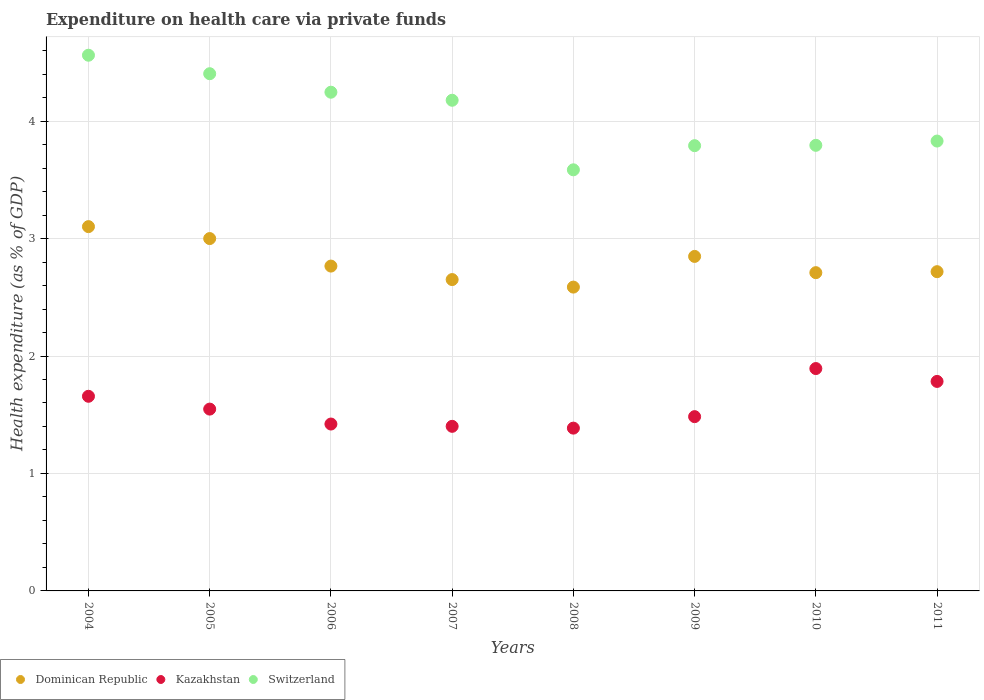Is the number of dotlines equal to the number of legend labels?
Make the answer very short. Yes. What is the expenditure made on health care in Switzerland in 2005?
Give a very brief answer. 4.4. Across all years, what is the maximum expenditure made on health care in Dominican Republic?
Offer a very short reply. 3.1. Across all years, what is the minimum expenditure made on health care in Kazakhstan?
Your response must be concise. 1.39. What is the total expenditure made on health care in Switzerland in the graph?
Ensure brevity in your answer.  32.39. What is the difference between the expenditure made on health care in Switzerland in 2004 and that in 2006?
Keep it short and to the point. 0.31. What is the difference between the expenditure made on health care in Kazakhstan in 2006 and the expenditure made on health care in Switzerland in 2007?
Your answer should be very brief. -2.76. What is the average expenditure made on health care in Switzerland per year?
Your response must be concise. 4.05. In the year 2010, what is the difference between the expenditure made on health care in Dominican Republic and expenditure made on health care in Switzerland?
Make the answer very short. -1.08. What is the ratio of the expenditure made on health care in Switzerland in 2008 to that in 2009?
Your answer should be compact. 0.95. Is the difference between the expenditure made on health care in Dominican Republic in 2010 and 2011 greater than the difference between the expenditure made on health care in Switzerland in 2010 and 2011?
Your answer should be compact. Yes. What is the difference between the highest and the second highest expenditure made on health care in Switzerland?
Your answer should be very brief. 0.16. What is the difference between the highest and the lowest expenditure made on health care in Dominican Republic?
Offer a terse response. 0.51. Is the expenditure made on health care in Switzerland strictly greater than the expenditure made on health care in Kazakhstan over the years?
Keep it short and to the point. Yes. How many dotlines are there?
Provide a short and direct response. 3. How many years are there in the graph?
Provide a succinct answer. 8. Are the values on the major ticks of Y-axis written in scientific E-notation?
Keep it short and to the point. No. Does the graph contain any zero values?
Offer a very short reply. No. Where does the legend appear in the graph?
Offer a terse response. Bottom left. How many legend labels are there?
Provide a short and direct response. 3. What is the title of the graph?
Your answer should be compact. Expenditure on health care via private funds. Does "Papua New Guinea" appear as one of the legend labels in the graph?
Provide a succinct answer. No. What is the label or title of the Y-axis?
Offer a terse response. Health expenditure (as % of GDP). What is the Health expenditure (as % of GDP) of Dominican Republic in 2004?
Your response must be concise. 3.1. What is the Health expenditure (as % of GDP) in Kazakhstan in 2004?
Keep it short and to the point. 1.66. What is the Health expenditure (as % of GDP) in Switzerland in 2004?
Your answer should be compact. 4.56. What is the Health expenditure (as % of GDP) of Dominican Republic in 2005?
Your response must be concise. 3. What is the Health expenditure (as % of GDP) in Kazakhstan in 2005?
Your answer should be very brief. 1.55. What is the Health expenditure (as % of GDP) of Switzerland in 2005?
Ensure brevity in your answer.  4.4. What is the Health expenditure (as % of GDP) in Dominican Republic in 2006?
Offer a very short reply. 2.77. What is the Health expenditure (as % of GDP) in Kazakhstan in 2006?
Keep it short and to the point. 1.42. What is the Health expenditure (as % of GDP) of Switzerland in 2006?
Make the answer very short. 4.25. What is the Health expenditure (as % of GDP) in Dominican Republic in 2007?
Your answer should be compact. 2.65. What is the Health expenditure (as % of GDP) in Kazakhstan in 2007?
Make the answer very short. 1.4. What is the Health expenditure (as % of GDP) of Switzerland in 2007?
Provide a short and direct response. 4.18. What is the Health expenditure (as % of GDP) of Dominican Republic in 2008?
Offer a terse response. 2.59. What is the Health expenditure (as % of GDP) of Kazakhstan in 2008?
Provide a succinct answer. 1.39. What is the Health expenditure (as % of GDP) of Switzerland in 2008?
Offer a terse response. 3.59. What is the Health expenditure (as % of GDP) in Dominican Republic in 2009?
Your response must be concise. 2.85. What is the Health expenditure (as % of GDP) in Kazakhstan in 2009?
Your response must be concise. 1.48. What is the Health expenditure (as % of GDP) of Switzerland in 2009?
Offer a very short reply. 3.79. What is the Health expenditure (as % of GDP) in Dominican Republic in 2010?
Offer a very short reply. 2.71. What is the Health expenditure (as % of GDP) of Kazakhstan in 2010?
Give a very brief answer. 1.89. What is the Health expenditure (as % of GDP) in Switzerland in 2010?
Keep it short and to the point. 3.79. What is the Health expenditure (as % of GDP) of Dominican Republic in 2011?
Offer a terse response. 2.72. What is the Health expenditure (as % of GDP) in Kazakhstan in 2011?
Provide a succinct answer. 1.78. What is the Health expenditure (as % of GDP) in Switzerland in 2011?
Your response must be concise. 3.83. Across all years, what is the maximum Health expenditure (as % of GDP) of Dominican Republic?
Your answer should be compact. 3.1. Across all years, what is the maximum Health expenditure (as % of GDP) of Kazakhstan?
Provide a short and direct response. 1.89. Across all years, what is the maximum Health expenditure (as % of GDP) in Switzerland?
Offer a very short reply. 4.56. Across all years, what is the minimum Health expenditure (as % of GDP) in Dominican Republic?
Offer a very short reply. 2.59. Across all years, what is the minimum Health expenditure (as % of GDP) in Kazakhstan?
Your response must be concise. 1.39. Across all years, what is the minimum Health expenditure (as % of GDP) in Switzerland?
Offer a very short reply. 3.59. What is the total Health expenditure (as % of GDP) in Dominican Republic in the graph?
Offer a very short reply. 22.38. What is the total Health expenditure (as % of GDP) of Kazakhstan in the graph?
Offer a very short reply. 12.57. What is the total Health expenditure (as % of GDP) in Switzerland in the graph?
Offer a very short reply. 32.39. What is the difference between the Health expenditure (as % of GDP) of Dominican Republic in 2004 and that in 2005?
Offer a very short reply. 0.1. What is the difference between the Health expenditure (as % of GDP) of Kazakhstan in 2004 and that in 2005?
Ensure brevity in your answer.  0.11. What is the difference between the Health expenditure (as % of GDP) in Switzerland in 2004 and that in 2005?
Your response must be concise. 0.16. What is the difference between the Health expenditure (as % of GDP) of Dominican Republic in 2004 and that in 2006?
Offer a very short reply. 0.34. What is the difference between the Health expenditure (as % of GDP) in Kazakhstan in 2004 and that in 2006?
Offer a very short reply. 0.24. What is the difference between the Health expenditure (as % of GDP) of Switzerland in 2004 and that in 2006?
Provide a short and direct response. 0.31. What is the difference between the Health expenditure (as % of GDP) in Dominican Republic in 2004 and that in 2007?
Make the answer very short. 0.45. What is the difference between the Health expenditure (as % of GDP) in Kazakhstan in 2004 and that in 2007?
Your response must be concise. 0.26. What is the difference between the Health expenditure (as % of GDP) in Switzerland in 2004 and that in 2007?
Provide a short and direct response. 0.38. What is the difference between the Health expenditure (as % of GDP) of Dominican Republic in 2004 and that in 2008?
Your answer should be compact. 0.51. What is the difference between the Health expenditure (as % of GDP) in Kazakhstan in 2004 and that in 2008?
Keep it short and to the point. 0.27. What is the difference between the Health expenditure (as % of GDP) of Switzerland in 2004 and that in 2008?
Offer a very short reply. 0.98. What is the difference between the Health expenditure (as % of GDP) of Dominican Republic in 2004 and that in 2009?
Ensure brevity in your answer.  0.25. What is the difference between the Health expenditure (as % of GDP) in Kazakhstan in 2004 and that in 2009?
Keep it short and to the point. 0.17. What is the difference between the Health expenditure (as % of GDP) in Switzerland in 2004 and that in 2009?
Keep it short and to the point. 0.77. What is the difference between the Health expenditure (as % of GDP) of Dominican Republic in 2004 and that in 2010?
Your answer should be compact. 0.39. What is the difference between the Health expenditure (as % of GDP) in Kazakhstan in 2004 and that in 2010?
Give a very brief answer. -0.24. What is the difference between the Health expenditure (as % of GDP) of Switzerland in 2004 and that in 2010?
Ensure brevity in your answer.  0.77. What is the difference between the Health expenditure (as % of GDP) in Dominican Republic in 2004 and that in 2011?
Your response must be concise. 0.38. What is the difference between the Health expenditure (as % of GDP) in Kazakhstan in 2004 and that in 2011?
Keep it short and to the point. -0.13. What is the difference between the Health expenditure (as % of GDP) of Switzerland in 2004 and that in 2011?
Offer a terse response. 0.73. What is the difference between the Health expenditure (as % of GDP) of Dominican Republic in 2005 and that in 2006?
Make the answer very short. 0.23. What is the difference between the Health expenditure (as % of GDP) in Kazakhstan in 2005 and that in 2006?
Provide a succinct answer. 0.13. What is the difference between the Health expenditure (as % of GDP) of Switzerland in 2005 and that in 2006?
Ensure brevity in your answer.  0.16. What is the difference between the Health expenditure (as % of GDP) of Dominican Republic in 2005 and that in 2007?
Provide a short and direct response. 0.35. What is the difference between the Health expenditure (as % of GDP) of Kazakhstan in 2005 and that in 2007?
Offer a very short reply. 0.15. What is the difference between the Health expenditure (as % of GDP) of Switzerland in 2005 and that in 2007?
Offer a very short reply. 0.23. What is the difference between the Health expenditure (as % of GDP) of Dominican Republic in 2005 and that in 2008?
Provide a succinct answer. 0.41. What is the difference between the Health expenditure (as % of GDP) in Kazakhstan in 2005 and that in 2008?
Offer a very short reply. 0.16. What is the difference between the Health expenditure (as % of GDP) in Switzerland in 2005 and that in 2008?
Your answer should be compact. 0.82. What is the difference between the Health expenditure (as % of GDP) in Dominican Republic in 2005 and that in 2009?
Give a very brief answer. 0.15. What is the difference between the Health expenditure (as % of GDP) in Kazakhstan in 2005 and that in 2009?
Give a very brief answer. 0.06. What is the difference between the Health expenditure (as % of GDP) of Switzerland in 2005 and that in 2009?
Provide a succinct answer. 0.61. What is the difference between the Health expenditure (as % of GDP) of Dominican Republic in 2005 and that in 2010?
Your response must be concise. 0.29. What is the difference between the Health expenditure (as % of GDP) of Kazakhstan in 2005 and that in 2010?
Give a very brief answer. -0.35. What is the difference between the Health expenditure (as % of GDP) of Switzerland in 2005 and that in 2010?
Ensure brevity in your answer.  0.61. What is the difference between the Health expenditure (as % of GDP) in Dominican Republic in 2005 and that in 2011?
Make the answer very short. 0.28. What is the difference between the Health expenditure (as % of GDP) of Kazakhstan in 2005 and that in 2011?
Your answer should be very brief. -0.24. What is the difference between the Health expenditure (as % of GDP) in Switzerland in 2005 and that in 2011?
Keep it short and to the point. 0.57. What is the difference between the Health expenditure (as % of GDP) in Dominican Republic in 2006 and that in 2007?
Provide a succinct answer. 0.11. What is the difference between the Health expenditure (as % of GDP) in Kazakhstan in 2006 and that in 2007?
Your response must be concise. 0.02. What is the difference between the Health expenditure (as % of GDP) in Switzerland in 2006 and that in 2007?
Your answer should be very brief. 0.07. What is the difference between the Health expenditure (as % of GDP) in Dominican Republic in 2006 and that in 2008?
Make the answer very short. 0.18. What is the difference between the Health expenditure (as % of GDP) in Kazakhstan in 2006 and that in 2008?
Your answer should be very brief. 0.03. What is the difference between the Health expenditure (as % of GDP) of Switzerland in 2006 and that in 2008?
Make the answer very short. 0.66. What is the difference between the Health expenditure (as % of GDP) of Dominican Republic in 2006 and that in 2009?
Offer a terse response. -0.08. What is the difference between the Health expenditure (as % of GDP) of Kazakhstan in 2006 and that in 2009?
Your response must be concise. -0.06. What is the difference between the Health expenditure (as % of GDP) in Switzerland in 2006 and that in 2009?
Offer a very short reply. 0.46. What is the difference between the Health expenditure (as % of GDP) in Dominican Republic in 2006 and that in 2010?
Keep it short and to the point. 0.06. What is the difference between the Health expenditure (as % of GDP) of Kazakhstan in 2006 and that in 2010?
Make the answer very short. -0.47. What is the difference between the Health expenditure (as % of GDP) of Switzerland in 2006 and that in 2010?
Your answer should be compact. 0.45. What is the difference between the Health expenditure (as % of GDP) of Dominican Republic in 2006 and that in 2011?
Keep it short and to the point. 0.05. What is the difference between the Health expenditure (as % of GDP) in Kazakhstan in 2006 and that in 2011?
Provide a short and direct response. -0.36. What is the difference between the Health expenditure (as % of GDP) in Switzerland in 2006 and that in 2011?
Keep it short and to the point. 0.42. What is the difference between the Health expenditure (as % of GDP) of Dominican Republic in 2007 and that in 2008?
Make the answer very short. 0.06. What is the difference between the Health expenditure (as % of GDP) of Kazakhstan in 2007 and that in 2008?
Keep it short and to the point. 0.02. What is the difference between the Health expenditure (as % of GDP) in Switzerland in 2007 and that in 2008?
Offer a terse response. 0.59. What is the difference between the Health expenditure (as % of GDP) of Dominican Republic in 2007 and that in 2009?
Provide a short and direct response. -0.2. What is the difference between the Health expenditure (as % of GDP) of Kazakhstan in 2007 and that in 2009?
Provide a succinct answer. -0.08. What is the difference between the Health expenditure (as % of GDP) of Switzerland in 2007 and that in 2009?
Give a very brief answer. 0.39. What is the difference between the Health expenditure (as % of GDP) in Dominican Republic in 2007 and that in 2010?
Make the answer very short. -0.06. What is the difference between the Health expenditure (as % of GDP) of Kazakhstan in 2007 and that in 2010?
Provide a short and direct response. -0.49. What is the difference between the Health expenditure (as % of GDP) in Switzerland in 2007 and that in 2010?
Offer a terse response. 0.38. What is the difference between the Health expenditure (as % of GDP) in Dominican Republic in 2007 and that in 2011?
Give a very brief answer. -0.07. What is the difference between the Health expenditure (as % of GDP) of Kazakhstan in 2007 and that in 2011?
Give a very brief answer. -0.38. What is the difference between the Health expenditure (as % of GDP) of Switzerland in 2007 and that in 2011?
Keep it short and to the point. 0.35. What is the difference between the Health expenditure (as % of GDP) in Dominican Republic in 2008 and that in 2009?
Your answer should be very brief. -0.26. What is the difference between the Health expenditure (as % of GDP) in Kazakhstan in 2008 and that in 2009?
Your answer should be compact. -0.1. What is the difference between the Health expenditure (as % of GDP) of Switzerland in 2008 and that in 2009?
Make the answer very short. -0.21. What is the difference between the Health expenditure (as % of GDP) in Dominican Republic in 2008 and that in 2010?
Offer a very short reply. -0.12. What is the difference between the Health expenditure (as % of GDP) in Kazakhstan in 2008 and that in 2010?
Make the answer very short. -0.51. What is the difference between the Health expenditure (as % of GDP) in Switzerland in 2008 and that in 2010?
Ensure brevity in your answer.  -0.21. What is the difference between the Health expenditure (as % of GDP) of Dominican Republic in 2008 and that in 2011?
Ensure brevity in your answer.  -0.13. What is the difference between the Health expenditure (as % of GDP) of Kazakhstan in 2008 and that in 2011?
Provide a succinct answer. -0.4. What is the difference between the Health expenditure (as % of GDP) in Switzerland in 2008 and that in 2011?
Give a very brief answer. -0.24. What is the difference between the Health expenditure (as % of GDP) in Dominican Republic in 2009 and that in 2010?
Your answer should be compact. 0.14. What is the difference between the Health expenditure (as % of GDP) of Kazakhstan in 2009 and that in 2010?
Your answer should be compact. -0.41. What is the difference between the Health expenditure (as % of GDP) of Switzerland in 2009 and that in 2010?
Offer a terse response. -0. What is the difference between the Health expenditure (as % of GDP) of Dominican Republic in 2009 and that in 2011?
Provide a short and direct response. 0.13. What is the difference between the Health expenditure (as % of GDP) of Kazakhstan in 2009 and that in 2011?
Offer a very short reply. -0.3. What is the difference between the Health expenditure (as % of GDP) of Switzerland in 2009 and that in 2011?
Your answer should be compact. -0.04. What is the difference between the Health expenditure (as % of GDP) in Dominican Republic in 2010 and that in 2011?
Offer a terse response. -0.01. What is the difference between the Health expenditure (as % of GDP) of Kazakhstan in 2010 and that in 2011?
Keep it short and to the point. 0.11. What is the difference between the Health expenditure (as % of GDP) in Switzerland in 2010 and that in 2011?
Your answer should be very brief. -0.04. What is the difference between the Health expenditure (as % of GDP) in Dominican Republic in 2004 and the Health expenditure (as % of GDP) in Kazakhstan in 2005?
Offer a terse response. 1.55. What is the difference between the Health expenditure (as % of GDP) in Dominican Republic in 2004 and the Health expenditure (as % of GDP) in Switzerland in 2005?
Offer a very short reply. -1.3. What is the difference between the Health expenditure (as % of GDP) of Kazakhstan in 2004 and the Health expenditure (as % of GDP) of Switzerland in 2005?
Make the answer very short. -2.75. What is the difference between the Health expenditure (as % of GDP) of Dominican Republic in 2004 and the Health expenditure (as % of GDP) of Kazakhstan in 2006?
Keep it short and to the point. 1.68. What is the difference between the Health expenditure (as % of GDP) of Dominican Republic in 2004 and the Health expenditure (as % of GDP) of Switzerland in 2006?
Provide a short and direct response. -1.14. What is the difference between the Health expenditure (as % of GDP) in Kazakhstan in 2004 and the Health expenditure (as % of GDP) in Switzerland in 2006?
Offer a very short reply. -2.59. What is the difference between the Health expenditure (as % of GDP) of Dominican Republic in 2004 and the Health expenditure (as % of GDP) of Kazakhstan in 2007?
Your answer should be very brief. 1.7. What is the difference between the Health expenditure (as % of GDP) in Dominican Republic in 2004 and the Health expenditure (as % of GDP) in Switzerland in 2007?
Offer a very short reply. -1.08. What is the difference between the Health expenditure (as % of GDP) of Kazakhstan in 2004 and the Health expenditure (as % of GDP) of Switzerland in 2007?
Offer a very short reply. -2.52. What is the difference between the Health expenditure (as % of GDP) of Dominican Republic in 2004 and the Health expenditure (as % of GDP) of Kazakhstan in 2008?
Ensure brevity in your answer.  1.72. What is the difference between the Health expenditure (as % of GDP) of Dominican Republic in 2004 and the Health expenditure (as % of GDP) of Switzerland in 2008?
Offer a terse response. -0.48. What is the difference between the Health expenditure (as % of GDP) in Kazakhstan in 2004 and the Health expenditure (as % of GDP) in Switzerland in 2008?
Offer a terse response. -1.93. What is the difference between the Health expenditure (as % of GDP) of Dominican Republic in 2004 and the Health expenditure (as % of GDP) of Kazakhstan in 2009?
Offer a very short reply. 1.62. What is the difference between the Health expenditure (as % of GDP) in Dominican Republic in 2004 and the Health expenditure (as % of GDP) in Switzerland in 2009?
Your response must be concise. -0.69. What is the difference between the Health expenditure (as % of GDP) of Kazakhstan in 2004 and the Health expenditure (as % of GDP) of Switzerland in 2009?
Provide a succinct answer. -2.13. What is the difference between the Health expenditure (as % of GDP) of Dominican Republic in 2004 and the Health expenditure (as % of GDP) of Kazakhstan in 2010?
Offer a very short reply. 1.21. What is the difference between the Health expenditure (as % of GDP) in Dominican Republic in 2004 and the Health expenditure (as % of GDP) in Switzerland in 2010?
Your answer should be very brief. -0.69. What is the difference between the Health expenditure (as % of GDP) in Kazakhstan in 2004 and the Health expenditure (as % of GDP) in Switzerland in 2010?
Ensure brevity in your answer.  -2.14. What is the difference between the Health expenditure (as % of GDP) in Dominican Republic in 2004 and the Health expenditure (as % of GDP) in Kazakhstan in 2011?
Offer a terse response. 1.32. What is the difference between the Health expenditure (as % of GDP) of Dominican Republic in 2004 and the Health expenditure (as % of GDP) of Switzerland in 2011?
Keep it short and to the point. -0.73. What is the difference between the Health expenditure (as % of GDP) in Kazakhstan in 2004 and the Health expenditure (as % of GDP) in Switzerland in 2011?
Keep it short and to the point. -2.17. What is the difference between the Health expenditure (as % of GDP) of Dominican Republic in 2005 and the Health expenditure (as % of GDP) of Kazakhstan in 2006?
Your answer should be compact. 1.58. What is the difference between the Health expenditure (as % of GDP) in Dominican Republic in 2005 and the Health expenditure (as % of GDP) in Switzerland in 2006?
Give a very brief answer. -1.25. What is the difference between the Health expenditure (as % of GDP) in Kazakhstan in 2005 and the Health expenditure (as % of GDP) in Switzerland in 2006?
Give a very brief answer. -2.7. What is the difference between the Health expenditure (as % of GDP) in Dominican Republic in 2005 and the Health expenditure (as % of GDP) in Kazakhstan in 2007?
Ensure brevity in your answer.  1.6. What is the difference between the Health expenditure (as % of GDP) of Dominican Republic in 2005 and the Health expenditure (as % of GDP) of Switzerland in 2007?
Your answer should be very brief. -1.18. What is the difference between the Health expenditure (as % of GDP) in Kazakhstan in 2005 and the Health expenditure (as % of GDP) in Switzerland in 2007?
Your answer should be compact. -2.63. What is the difference between the Health expenditure (as % of GDP) of Dominican Republic in 2005 and the Health expenditure (as % of GDP) of Kazakhstan in 2008?
Make the answer very short. 1.61. What is the difference between the Health expenditure (as % of GDP) of Dominican Republic in 2005 and the Health expenditure (as % of GDP) of Switzerland in 2008?
Give a very brief answer. -0.59. What is the difference between the Health expenditure (as % of GDP) of Kazakhstan in 2005 and the Health expenditure (as % of GDP) of Switzerland in 2008?
Offer a very short reply. -2.04. What is the difference between the Health expenditure (as % of GDP) of Dominican Republic in 2005 and the Health expenditure (as % of GDP) of Kazakhstan in 2009?
Provide a short and direct response. 1.52. What is the difference between the Health expenditure (as % of GDP) in Dominican Republic in 2005 and the Health expenditure (as % of GDP) in Switzerland in 2009?
Offer a very short reply. -0.79. What is the difference between the Health expenditure (as % of GDP) of Kazakhstan in 2005 and the Health expenditure (as % of GDP) of Switzerland in 2009?
Your response must be concise. -2.24. What is the difference between the Health expenditure (as % of GDP) of Dominican Republic in 2005 and the Health expenditure (as % of GDP) of Kazakhstan in 2010?
Keep it short and to the point. 1.11. What is the difference between the Health expenditure (as % of GDP) in Dominican Republic in 2005 and the Health expenditure (as % of GDP) in Switzerland in 2010?
Provide a short and direct response. -0.79. What is the difference between the Health expenditure (as % of GDP) of Kazakhstan in 2005 and the Health expenditure (as % of GDP) of Switzerland in 2010?
Keep it short and to the point. -2.25. What is the difference between the Health expenditure (as % of GDP) of Dominican Republic in 2005 and the Health expenditure (as % of GDP) of Kazakhstan in 2011?
Offer a terse response. 1.22. What is the difference between the Health expenditure (as % of GDP) in Dominican Republic in 2005 and the Health expenditure (as % of GDP) in Switzerland in 2011?
Ensure brevity in your answer.  -0.83. What is the difference between the Health expenditure (as % of GDP) in Kazakhstan in 2005 and the Health expenditure (as % of GDP) in Switzerland in 2011?
Make the answer very short. -2.28. What is the difference between the Health expenditure (as % of GDP) in Dominican Republic in 2006 and the Health expenditure (as % of GDP) in Kazakhstan in 2007?
Provide a succinct answer. 1.36. What is the difference between the Health expenditure (as % of GDP) of Dominican Republic in 2006 and the Health expenditure (as % of GDP) of Switzerland in 2007?
Offer a very short reply. -1.41. What is the difference between the Health expenditure (as % of GDP) of Kazakhstan in 2006 and the Health expenditure (as % of GDP) of Switzerland in 2007?
Your answer should be compact. -2.76. What is the difference between the Health expenditure (as % of GDP) in Dominican Republic in 2006 and the Health expenditure (as % of GDP) in Kazakhstan in 2008?
Ensure brevity in your answer.  1.38. What is the difference between the Health expenditure (as % of GDP) in Dominican Republic in 2006 and the Health expenditure (as % of GDP) in Switzerland in 2008?
Make the answer very short. -0.82. What is the difference between the Health expenditure (as % of GDP) in Kazakhstan in 2006 and the Health expenditure (as % of GDP) in Switzerland in 2008?
Offer a very short reply. -2.16. What is the difference between the Health expenditure (as % of GDP) of Dominican Republic in 2006 and the Health expenditure (as % of GDP) of Kazakhstan in 2009?
Make the answer very short. 1.28. What is the difference between the Health expenditure (as % of GDP) in Dominican Republic in 2006 and the Health expenditure (as % of GDP) in Switzerland in 2009?
Offer a terse response. -1.03. What is the difference between the Health expenditure (as % of GDP) of Kazakhstan in 2006 and the Health expenditure (as % of GDP) of Switzerland in 2009?
Keep it short and to the point. -2.37. What is the difference between the Health expenditure (as % of GDP) of Dominican Republic in 2006 and the Health expenditure (as % of GDP) of Kazakhstan in 2010?
Give a very brief answer. 0.87. What is the difference between the Health expenditure (as % of GDP) in Dominican Republic in 2006 and the Health expenditure (as % of GDP) in Switzerland in 2010?
Your answer should be compact. -1.03. What is the difference between the Health expenditure (as % of GDP) of Kazakhstan in 2006 and the Health expenditure (as % of GDP) of Switzerland in 2010?
Your answer should be very brief. -2.37. What is the difference between the Health expenditure (as % of GDP) in Dominican Republic in 2006 and the Health expenditure (as % of GDP) in Kazakhstan in 2011?
Keep it short and to the point. 0.98. What is the difference between the Health expenditure (as % of GDP) in Dominican Republic in 2006 and the Health expenditure (as % of GDP) in Switzerland in 2011?
Make the answer very short. -1.06. What is the difference between the Health expenditure (as % of GDP) in Kazakhstan in 2006 and the Health expenditure (as % of GDP) in Switzerland in 2011?
Provide a short and direct response. -2.41. What is the difference between the Health expenditure (as % of GDP) in Dominican Republic in 2007 and the Health expenditure (as % of GDP) in Kazakhstan in 2008?
Your answer should be compact. 1.26. What is the difference between the Health expenditure (as % of GDP) in Dominican Republic in 2007 and the Health expenditure (as % of GDP) in Switzerland in 2008?
Provide a succinct answer. -0.93. What is the difference between the Health expenditure (as % of GDP) of Kazakhstan in 2007 and the Health expenditure (as % of GDP) of Switzerland in 2008?
Provide a succinct answer. -2.18. What is the difference between the Health expenditure (as % of GDP) in Dominican Republic in 2007 and the Health expenditure (as % of GDP) in Kazakhstan in 2009?
Your response must be concise. 1.17. What is the difference between the Health expenditure (as % of GDP) of Dominican Republic in 2007 and the Health expenditure (as % of GDP) of Switzerland in 2009?
Provide a succinct answer. -1.14. What is the difference between the Health expenditure (as % of GDP) in Kazakhstan in 2007 and the Health expenditure (as % of GDP) in Switzerland in 2009?
Ensure brevity in your answer.  -2.39. What is the difference between the Health expenditure (as % of GDP) in Dominican Republic in 2007 and the Health expenditure (as % of GDP) in Kazakhstan in 2010?
Ensure brevity in your answer.  0.76. What is the difference between the Health expenditure (as % of GDP) in Dominican Republic in 2007 and the Health expenditure (as % of GDP) in Switzerland in 2010?
Make the answer very short. -1.14. What is the difference between the Health expenditure (as % of GDP) of Kazakhstan in 2007 and the Health expenditure (as % of GDP) of Switzerland in 2010?
Make the answer very short. -2.39. What is the difference between the Health expenditure (as % of GDP) in Dominican Republic in 2007 and the Health expenditure (as % of GDP) in Kazakhstan in 2011?
Provide a succinct answer. 0.87. What is the difference between the Health expenditure (as % of GDP) of Dominican Republic in 2007 and the Health expenditure (as % of GDP) of Switzerland in 2011?
Your answer should be compact. -1.18. What is the difference between the Health expenditure (as % of GDP) in Kazakhstan in 2007 and the Health expenditure (as % of GDP) in Switzerland in 2011?
Your answer should be very brief. -2.43. What is the difference between the Health expenditure (as % of GDP) of Dominican Republic in 2008 and the Health expenditure (as % of GDP) of Kazakhstan in 2009?
Your answer should be compact. 1.1. What is the difference between the Health expenditure (as % of GDP) in Dominican Republic in 2008 and the Health expenditure (as % of GDP) in Switzerland in 2009?
Offer a very short reply. -1.2. What is the difference between the Health expenditure (as % of GDP) of Kazakhstan in 2008 and the Health expenditure (as % of GDP) of Switzerland in 2009?
Offer a terse response. -2.4. What is the difference between the Health expenditure (as % of GDP) of Dominican Republic in 2008 and the Health expenditure (as % of GDP) of Kazakhstan in 2010?
Make the answer very short. 0.69. What is the difference between the Health expenditure (as % of GDP) of Dominican Republic in 2008 and the Health expenditure (as % of GDP) of Switzerland in 2010?
Your response must be concise. -1.21. What is the difference between the Health expenditure (as % of GDP) in Kazakhstan in 2008 and the Health expenditure (as % of GDP) in Switzerland in 2010?
Make the answer very short. -2.41. What is the difference between the Health expenditure (as % of GDP) in Dominican Republic in 2008 and the Health expenditure (as % of GDP) in Kazakhstan in 2011?
Offer a very short reply. 0.8. What is the difference between the Health expenditure (as % of GDP) in Dominican Republic in 2008 and the Health expenditure (as % of GDP) in Switzerland in 2011?
Your answer should be compact. -1.24. What is the difference between the Health expenditure (as % of GDP) of Kazakhstan in 2008 and the Health expenditure (as % of GDP) of Switzerland in 2011?
Your answer should be very brief. -2.44. What is the difference between the Health expenditure (as % of GDP) of Dominican Republic in 2009 and the Health expenditure (as % of GDP) of Kazakhstan in 2010?
Ensure brevity in your answer.  0.95. What is the difference between the Health expenditure (as % of GDP) in Dominican Republic in 2009 and the Health expenditure (as % of GDP) in Switzerland in 2010?
Your answer should be compact. -0.95. What is the difference between the Health expenditure (as % of GDP) in Kazakhstan in 2009 and the Health expenditure (as % of GDP) in Switzerland in 2010?
Your response must be concise. -2.31. What is the difference between the Health expenditure (as % of GDP) in Dominican Republic in 2009 and the Health expenditure (as % of GDP) in Kazakhstan in 2011?
Your answer should be very brief. 1.06. What is the difference between the Health expenditure (as % of GDP) of Dominican Republic in 2009 and the Health expenditure (as % of GDP) of Switzerland in 2011?
Provide a short and direct response. -0.98. What is the difference between the Health expenditure (as % of GDP) in Kazakhstan in 2009 and the Health expenditure (as % of GDP) in Switzerland in 2011?
Offer a very short reply. -2.35. What is the difference between the Health expenditure (as % of GDP) of Dominican Republic in 2010 and the Health expenditure (as % of GDP) of Kazakhstan in 2011?
Ensure brevity in your answer.  0.93. What is the difference between the Health expenditure (as % of GDP) in Dominican Republic in 2010 and the Health expenditure (as % of GDP) in Switzerland in 2011?
Your answer should be compact. -1.12. What is the difference between the Health expenditure (as % of GDP) of Kazakhstan in 2010 and the Health expenditure (as % of GDP) of Switzerland in 2011?
Provide a short and direct response. -1.94. What is the average Health expenditure (as % of GDP) in Dominican Republic per year?
Your answer should be compact. 2.8. What is the average Health expenditure (as % of GDP) of Kazakhstan per year?
Give a very brief answer. 1.57. What is the average Health expenditure (as % of GDP) in Switzerland per year?
Your answer should be compact. 4.05. In the year 2004, what is the difference between the Health expenditure (as % of GDP) in Dominican Republic and Health expenditure (as % of GDP) in Kazakhstan?
Offer a terse response. 1.44. In the year 2004, what is the difference between the Health expenditure (as % of GDP) of Dominican Republic and Health expenditure (as % of GDP) of Switzerland?
Give a very brief answer. -1.46. In the year 2004, what is the difference between the Health expenditure (as % of GDP) of Kazakhstan and Health expenditure (as % of GDP) of Switzerland?
Make the answer very short. -2.9. In the year 2005, what is the difference between the Health expenditure (as % of GDP) of Dominican Republic and Health expenditure (as % of GDP) of Kazakhstan?
Give a very brief answer. 1.45. In the year 2005, what is the difference between the Health expenditure (as % of GDP) of Dominican Republic and Health expenditure (as % of GDP) of Switzerland?
Make the answer very short. -1.4. In the year 2005, what is the difference between the Health expenditure (as % of GDP) of Kazakhstan and Health expenditure (as % of GDP) of Switzerland?
Your answer should be very brief. -2.86. In the year 2006, what is the difference between the Health expenditure (as % of GDP) of Dominican Republic and Health expenditure (as % of GDP) of Kazakhstan?
Your response must be concise. 1.34. In the year 2006, what is the difference between the Health expenditure (as % of GDP) in Dominican Republic and Health expenditure (as % of GDP) in Switzerland?
Offer a terse response. -1.48. In the year 2006, what is the difference between the Health expenditure (as % of GDP) of Kazakhstan and Health expenditure (as % of GDP) of Switzerland?
Offer a terse response. -2.83. In the year 2007, what is the difference between the Health expenditure (as % of GDP) in Dominican Republic and Health expenditure (as % of GDP) in Kazakhstan?
Offer a terse response. 1.25. In the year 2007, what is the difference between the Health expenditure (as % of GDP) in Dominican Republic and Health expenditure (as % of GDP) in Switzerland?
Keep it short and to the point. -1.53. In the year 2007, what is the difference between the Health expenditure (as % of GDP) in Kazakhstan and Health expenditure (as % of GDP) in Switzerland?
Your answer should be compact. -2.78. In the year 2008, what is the difference between the Health expenditure (as % of GDP) in Dominican Republic and Health expenditure (as % of GDP) in Kazakhstan?
Provide a short and direct response. 1.2. In the year 2008, what is the difference between the Health expenditure (as % of GDP) in Dominican Republic and Health expenditure (as % of GDP) in Switzerland?
Make the answer very short. -1. In the year 2008, what is the difference between the Health expenditure (as % of GDP) of Kazakhstan and Health expenditure (as % of GDP) of Switzerland?
Keep it short and to the point. -2.2. In the year 2009, what is the difference between the Health expenditure (as % of GDP) in Dominican Republic and Health expenditure (as % of GDP) in Kazakhstan?
Keep it short and to the point. 1.36. In the year 2009, what is the difference between the Health expenditure (as % of GDP) of Dominican Republic and Health expenditure (as % of GDP) of Switzerland?
Keep it short and to the point. -0.94. In the year 2009, what is the difference between the Health expenditure (as % of GDP) of Kazakhstan and Health expenditure (as % of GDP) of Switzerland?
Ensure brevity in your answer.  -2.31. In the year 2010, what is the difference between the Health expenditure (as % of GDP) of Dominican Republic and Health expenditure (as % of GDP) of Kazakhstan?
Provide a short and direct response. 0.82. In the year 2010, what is the difference between the Health expenditure (as % of GDP) of Dominican Republic and Health expenditure (as % of GDP) of Switzerland?
Make the answer very short. -1.08. In the year 2010, what is the difference between the Health expenditure (as % of GDP) of Kazakhstan and Health expenditure (as % of GDP) of Switzerland?
Provide a short and direct response. -1.9. In the year 2011, what is the difference between the Health expenditure (as % of GDP) in Dominican Republic and Health expenditure (as % of GDP) in Kazakhstan?
Make the answer very short. 0.93. In the year 2011, what is the difference between the Health expenditure (as % of GDP) in Dominican Republic and Health expenditure (as % of GDP) in Switzerland?
Offer a terse response. -1.11. In the year 2011, what is the difference between the Health expenditure (as % of GDP) of Kazakhstan and Health expenditure (as % of GDP) of Switzerland?
Your response must be concise. -2.05. What is the ratio of the Health expenditure (as % of GDP) of Dominican Republic in 2004 to that in 2005?
Your response must be concise. 1.03. What is the ratio of the Health expenditure (as % of GDP) of Kazakhstan in 2004 to that in 2005?
Offer a very short reply. 1.07. What is the ratio of the Health expenditure (as % of GDP) in Switzerland in 2004 to that in 2005?
Make the answer very short. 1.04. What is the ratio of the Health expenditure (as % of GDP) in Dominican Republic in 2004 to that in 2006?
Your answer should be compact. 1.12. What is the ratio of the Health expenditure (as % of GDP) in Kazakhstan in 2004 to that in 2006?
Keep it short and to the point. 1.17. What is the ratio of the Health expenditure (as % of GDP) in Switzerland in 2004 to that in 2006?
Provide a succinct answer. 1.07. What is the ratio of the Health expenditure (as % of GDP) of Dominican Republic in 2004 to that in 2007?
Give a very brief answer. 1.17. What is the ratio of the Health expenditure (as % of GDP) in Kazakhstan in 2004 to that in 2007?
Your answer should be very brief. 1.18. What is the ratio of the Health expenditure (as % of GDP) of Switzerland in 2004 to that in 2007?
Your answer should be compact. 1.09. What is the ratio of the Health expenditure (as % of GDP) in Dominican Republic in 2004 to that in 2008?
Offer a very short reply. 1.2. What is the ratio of the Health expenditure (as % of GDP) of Kazakhstan in 2004 to that in 2008?
Your response must be concise. 1.2. What is the ratio of the Health expenditure (as % of GDP) of Switzerland in 2004 to that in 2008?
Your answer should be compact. 1.27. What is the ratio of the Health expenditure (as % of GDP) of Dominican Republic in 2004 to that in 2009?
Provide a succinct answer. 1.09. What is the ratio of the Health expenditure (as % of GDP) of Kazakhstan in 2004 to that in 2009?
Ensure brevity in your answer.  1.12. What is the ratio of the Health expenditure (as % of GDP) of Switzerland in 2004 to that in 2009?
Your response must be concise. 1.2. What is the ratio of the Health expenditure (as % of GDP) of Dominican Republic in 2004 to that in 2010?
Make the answer very short. 1.14. What is the ratio of the Health expenditure (as % of GDP) of Kazakhstan in 2004 to that in 2010?
Ensure brevity in your answer.  0.88. What is the ratio of the Health expenditure (as % of GDP) in Switzerland in 2004 to that in 2010?
Your answer should be compact. 1.2. What is the ratio of the Health expenditure (as % of GDP) of Dominican Republic in 2004 to that in 2011?
Make the answer very short. 1.14. What is the ratio of the Health expenditure (as % of GDP) of Kazakhstan in 2004 to that in 2011?
Your answer should be compact. 0.93. What is the ratio of the Health expenditure (as % of GDP) in Switzerland in 2004 to that in 2011?
Give a very brief answer. 1.19. What is the ratio of the Health expenditure (as % of GDP) in Dominican Republic in 2005 to that in 2006?
Your answer should be very brief. 1.08. What is the ratio of the Health expenditure (as % of GDP) of Kazakhstan in 2005 to that in 2006?
Ensure brevity in your answer.  1.09. What is the ratio of the Health expenditure (as % of GDP) in Switzerland in 2005 to that in 2006?
Provide a succinct answer. 1.04. What is the ratio of the Health expenditure (as % of GDP) of Dominican Republic in 2005 to that in 2007?
Your answer should be very brief. 1.13. What is the ratio of the Health expenditure (as % of GDP) in Kazakhstan in 2005 to that in 2007?
Offer a terse response. 1.1. What is the ratio of the Health expenditure (as % of GDP) in Switzerland in 2005 to that in 2007?
Your response must be concise. 1.05. What is the ratio of the Health expenditure (as % of GDP) of Dominican Republic in 2005 to that in 2008?
Give a very brief answer. 1.16. What is the ratio of the Health expenditure (as % of GDP) in Kazakhstan in 2005 to that in 2008?
Make the answer very short. 1.12. What is the ratio of the Health expenditure (as % of GDP) in Switzerland in 2005 to that in 2008?
Offer a very short reply. 1.23. What is the ratio of the Health expenditure (as % of GDP) of Dominican Republic in 2005 to that in 2009?
Keep it short and to the point. 1.05. What is the ratio of the Health expenditure (as % of GDP) of Kazakhstan in 2005 to that in 2009?
Your answer should be very brief. 1.04. What is the ratio of the Health expenditure (as % of GDP) in Switzerland in 2005 to that in 2009?
Offer a very short reply. 1.16. What is the ratio of the Health expenditure (as % of GDP) in Dominican Republic in 2005 to that in 2010?
Give a very brief answer. 1.11. What is the ratio of the Health expenditure (as % of GDP) of Kazakhstan in 2005 to that in 2010?
Keep it short and to the point. 0.82. What is the ratio of the Health expenditure (as % of GDP) in Switzerland in 2005 to that in 2010?
Your answer should be very brief. 1.16. What is the ratio of the Health expenditure (as % of GDP) in Dominican Republic in 2005 to that in 2011?
Ensure brevity in your answer.  1.1. What is the ratio of the Health expenditure (as % of GDP) of Kazakhstan in 2005 to that in 2011?
Make the answer very short. 0.87. What is the ratio of the Health expenditure (as % of GDP) in Switzerland in 2005 to that in 2011?
Provide a short and direct response. 1.15. What is the ratio of the Health expenditure (as % of GDP) of Dominican Republic in 2006 to that in 2007?
Offer a terse response. 1.04. What is the ratio of the Health expenditure (as % of GDP) in Kazakhstan in 2006 to that in 2007?
Provide a short and direct response. 1.01. What is the ratio of the Health expenditure (as % of GDP) of Switzerland in 2006 to that in 2007?
Your answer should be very brief. 1.02. What is the ratio of the Health expenditure (as % of GDP) of Dominican Republic in 2006 to that in 2008?
Offer a terse response. 1.07. What is the ratio of the Health expenditure (as % of GDP) in Kazakhstan in 2006 to that in 2008?
Provide a short and direct response. 1.03. What is the ratio of the Health expenditure (as % of GDP) of Switzerland in 2006 to that in 2008?
Offer a very short reply. 1.18. What is the ratio of the Health expenditure (as % of GDP) of Dominican Republic in 2006 to that in 2009?
Your answer should be very brief. 0.97. What is the ratio of the Health expenditure (as % of GDP) in Kazakhstan in 2006 to that in 2009?
Your answer should be compact. 0.96. What is the ratio of the Health expenditure (as % of GDP) in Switzerland in 2006 to that in 2009?
Offer a very short reply. 1.12. What is the ratio of the Health expenditure (as % of GDP) in Dominican Republic in 2006 to that in 2010?
Provide a short and direct response. 1.02. What is the ratio of the Health expenditure (as % of GDP) of Kazakhstan in 2006 to that in 2010?
Give a very brief answer. 0.75. What is the ratio of the Health expenditure (as % of GDP) in Switzerland in 2006 to that in 2010?
Provide a succinct answer. 1.12. What is the ratio of the Health expenditure (as % of GDP) in Dominican Republic in 2006 to that in 2011?
Offer a very short reply. 1.02. What is the ratio of the Health expenditure (as % of GDP) of Kazakhstan in 2006 to that in 2011?
Offer a very short reply. 0.8. What is the ratio of the Health expenditure (as % of GDP) of Switzerland in 2006 to that in 2011?
Provide a succinct answer. 1.11. What is the ratio of the Health expenditure (as % of GDP) in Dominican Republic in 2007 to that in 2008?
Make the answer very short. 1.02. What is the ratio of the Health expenditure (as % of GDP) in Kazakhstan in 2007 to that in 2008?
Ensure brevity in your answer.  1.01. What is the ratio of the Health expenditure (as % of GDP) of Switzerland in 2007 to that in 2008?
Offer a very short reply. 1.17. What is the ratio of the Health expenditure (as % of GDP) of Dominican Republic in 2007 to that in 2009?
Offer a very short reply. 0.93. What is the ratio of the Health expenditure (as % of GDP) in Kazakhstan in 2007 to that in 2009?
Give a very brief answer. 0.94. What is the ratio of the Health expenditure (as % of GDP) in Switzerland in 2007 to that in 2009?
Offer a very short reply. 1.1. What is the ratio of the Health expenditure (as % of GDP) of Dominican Republic in 2007 to that in 2010?
Your response must be concise. 0.98. What is the ratio of the Health expenditure (as % of GDP) in Kazakhstan in 2007 to that in 2010?
Offer a very short reply. 0.74. What is the ratio of the Health expenditure (as % of GDP) in Switzerland in 2007 to that in 2010?
Provide a short and direct response. 1.1. What is the ratio of the Health expenditure (as % of GDP) of Dominican Republic in 2007 to that in 2011?
Ensure brevity in your answer.  0.98. What is the ratio of the Health expenditure (as % of GDP) in Kazakhstan in 2007 to that in 2011?
Ensure brevity in your answer.  0.79. What is the ratio of the Health expenditure (as % of GDP) in Switzerland in 2007 to that in 2011?
Your answer should be very brief. 1.09. What is the ratio of the Health expenditure (as % of GDP) of Dominican Republic in 2008 to that in 2009?
Provide a short and direct response. 0.91. What is the ratio of the Health expenditure (as % of GDP) in Kazakhstan in 2008 to that in 2009?
Your response must be concise. 0.93. What is the ratio of the Health expenditure (as % of GDP) in Switzerland in 2008 to that in 2009?
Offer a very short reply. 0.95. What is the ratio of the Health expenditure (as % of GDP) in Dominican Republic in 2008 to that in 2010?
Provide a short and direct response. 0.95. What is the ratio of the Health expenditure (as % of GDP) in Kazakhstan in 2008 to that in 2010?
Ensure brevity in your answer.  0.73. What is the ratio of the Health expenditure (as % of GDP) in Switzerland in 2008 to that in 2010?
Provide a short and direct response. 0.94. What is the ratio of the Health expenditure (as % of GDP) in Dominican Republic in 2008 to that in 2011?
Give a very brief answer. 0.95. What is the ratio of the Health expenditure (as % of GDP) of Kazakhstan in 2008 to that in 2011?
Offer a very short reply. 0.78. What is the ratio of the Health expenditure (as % of GDP) of Switzerland in 2008 to that in 2011?
Provide a short and direct response. 0.94. What is the ratio of the Health expenditure (as % of GDP) in Dominican Republic in 2009 to that in 2010?
Ensure brevity in your answer.  1.05. What is the ratio of the Health expenditure (as % of GDP) in Kazakhstan in 2009 to that in 2010?
Offer a very short reply. 0.78. What is the ratio of the Health expenditure (as % of GDP) in Dominican Republic in 2009 to that in 2011?
Keep it short and to the point. 1.05. What is the ratio of the Health expenditure (as % of GDP) of Kazakhstan in 2009 to that in 2011?
Provide a succinct answer. 0.83. What is the ratio of the Health expenditure (as % of GDP) of Switzerland in 2009 to that in 2011?
Offer a very short reply. 0.99. What is the ratio of the Health expenditure (as % of GDP) in Kazakhstan in 2010 to that in 2011?
Your response must be concise. 1.06. What is the ratio of the Health expenditure (as % of GDP) in Switzerland in 2010 to that in 2011?
Your answer should be compact. 0.99. What is the difference between the highest and the second highest Health expenditure (as % of GDP) in Dominican Republic?
Your answer should be very brief. 0.1. What is the difference between the highest and the second highest Health expenditure (as % of GDP) of Kazakhstan?
Provide a short and direct response. 0.11. What is the difference between the highest and the second highest Health expenditure (as % of GDP) of Switzerland?
Your answer should be compact. 0.16. What is the difference between the highest and the lowest Health expenditure (as % of GDP) of Dominican Republic?
Provide a short and direct response. 0.51. What is the difference between the highest and the lowest Health expenditure (as % of GDP) of Kazakhstan?
Provide a short and direct response. 0.51. What is the difference between the highest and the lowest Health expenditure (as % of GDP) in Switzerland?
Ensure brevity in your answer.  0.98. 